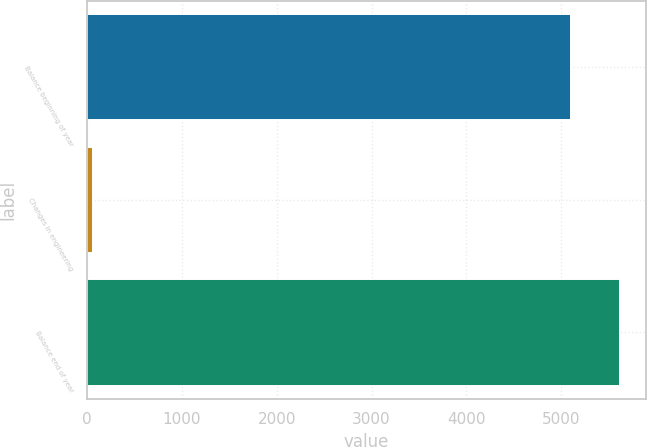Convert chart to OTSL. <chart><loc_0><loc_0><loc_500><loc_500><bar_chart><fcel>Balance beginning of year<fcel>Changes in engineering<fcel>Balance end of year<nl><fcel>5106<fcel>65<fcel>5616.5<nl></chart> 